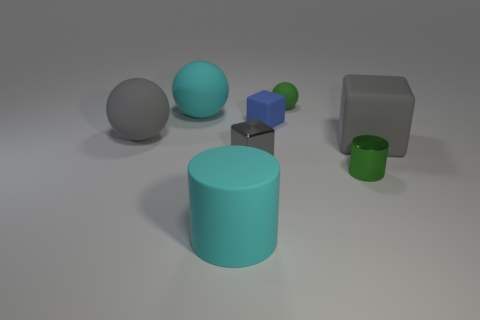Subtract all green matte spheres. How many spheres are left? 2 Subtract 1 cylinders. How many cylinders are left? 1 Add 1 big cyan things. How many objects exist? 9 Subtract all green spheres. How many spheres are left? 2 Subtract all cubes. How many objects are left? 5 Subtract all gray cylinders. Subtract all cyan blocks. How many cylinders are left? 2 Subtract all green spheres. How many blue cylinders are left? 0 Subtract all gray blocks. Subtract all large cyan spheres. How many objects are left? 5 Add 2 small balls. How many small balls are left? 3 Add 5 gray matte spheres. How many gray matte spheres exist? 6 